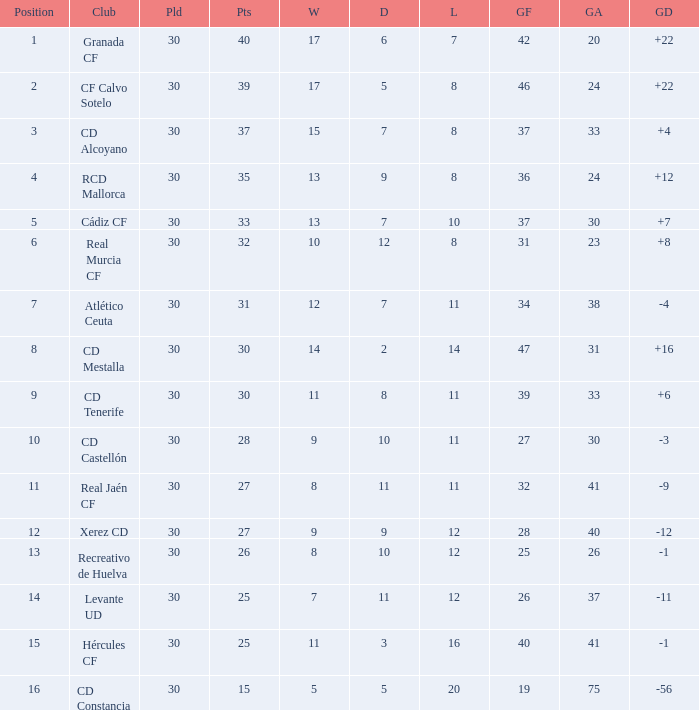Which Wins have a Goal Difference larger than 12, and a Club of granada cf, and Played larger than 30? None. 